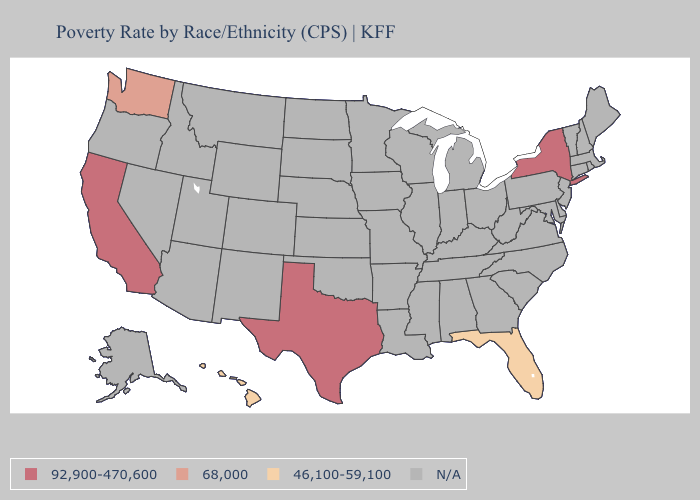Name the states that have a value in the range N/A?
Write a very short answer. Alabama, Alaska, Arizona, Arkansas, Colorado, Connecticut, Delaware, Georgia, Idaho, Illinois, Indiana, Iowa, Kansas, Kentucky, Louisiana, Maine, Maryland, Massachusetts, Michigan, Minnesota, Mississippi, Missouri, Montana, Nebraska, Nevada, New Hampshire, New Jersey, New Mexico, North Carolina, North Dakota, Ohio, Oklahoma, Oregon, Pennsylvania, Rhode Island, South Carolina, South Dakota, Tennessee, Utah, Vermont, Virginia, West Virginia, Wisconsin, Wyoming. Which states have the lowest value in the USA?
Answer briefly. Florida, Hawaii. Name the states that have a value in the range 92,900-470,600?
Answer briefly. California, New York, Texas. What is the highest value in the USA?
Write a very short answer. 92,900-470,600. Is the legend a continuous bar?
Quick response, please. No. Name the states that have a value in the range 68,000?
Short answer required. Washington. Which states hav the highest value in the Northeast?
Quick response, please. New York. Does Hawaii have the lowest value in the West?
Short answer required. Yes. 